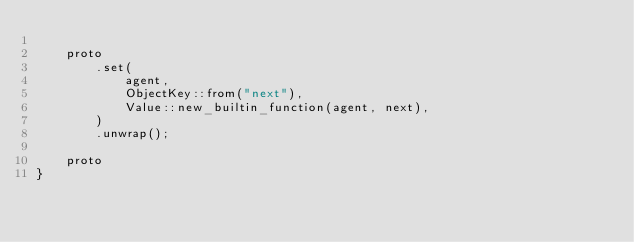Convert code to text. <code><loc_0><loc_0><loc_500><loc_500><_Rust_>
    proto
        .set(
            agent,
            ObjectKey::from("next"),
            Value::new_builtin_function(agent, next),
        )
        .unwrap();

    proto
}
</code> 